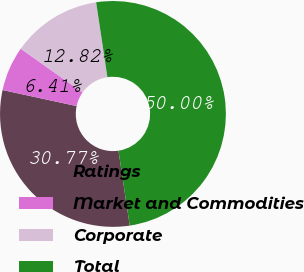Convert chart. <chart><loc_0><loc_0><loc_500><loc_500><pie_chart><fcel>Ratings<fcel>Market and Commodities<fcel>Corporate<fcel>Total<nl><fcel>30.77%<fcel>6.41%<fcel>12.82%<fcel>50.0%<nl></chart> 